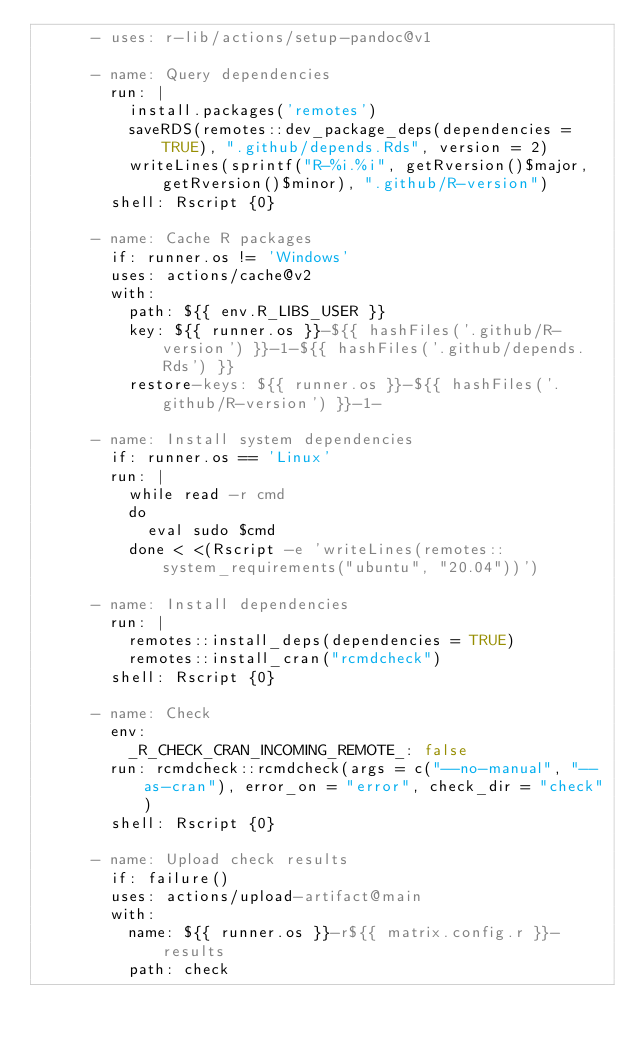Convert code to text. <code><loc_0><loc_0><loc_500><loc_500><_YAML_>      - uses: r-lib/actions/setup-pandoc@v1

      - name: Query dependencies
        run: |
          install.packages('remotes')
          saveRDS(remotes::dev_package_deps(dependencies = TRUE), ".github/depends.Rds", version = 2)
          writeLines(sprintf("R-%i.%i", getRversion()$major, getRversion()$minor), ".github/R-version")
        shell: Rscript {0}

      - name: Cache R packages
        if: runner.os != 'Windows'
        uses: actions/cache@v2
        with:
          path: ${{ env.R_LIBS_USER }}
          key: ${{ runner.os }}-${{ hashFiles('.github/R-version') }}-1-${{ hashFiles('.github/depends.Rds') }}
          restore-keys: ${{ runner.os }}-${{ hashFiles('.github/R-version') }}-1-

      - name: Install system dependencies
        if: runner.os == 'Linux'
        run: |
          while read -r cmd
          do
            eval sudo $cmd
          done < <(Rscript -e 'writeLines(remotes::system_requirements("ubuntu", "20.04"))')

      - name: Install dependencies
        run: |
          remotes::install_deps(dependencies = TRUE)
          remotes::install_cran("rcmdcheck")
        shell: Rscript {0}

      - name: Check
        env:
          _R_CHECK_CRAN_INCOMING_REMOTE_: false
        run: rcmdcheck::rcmdcheck(args = c("--no-manual", "--as-cran"), error_on = "error", check_dir = "check")
        shell: Rscript {0}

      - name: Upload check results
        if: failure()
        uses: actions/upload-artifact@main
        with:
          name: ${{ runner.os }}-r${{ matrix.config.r }}-results
          path: check
</code> 